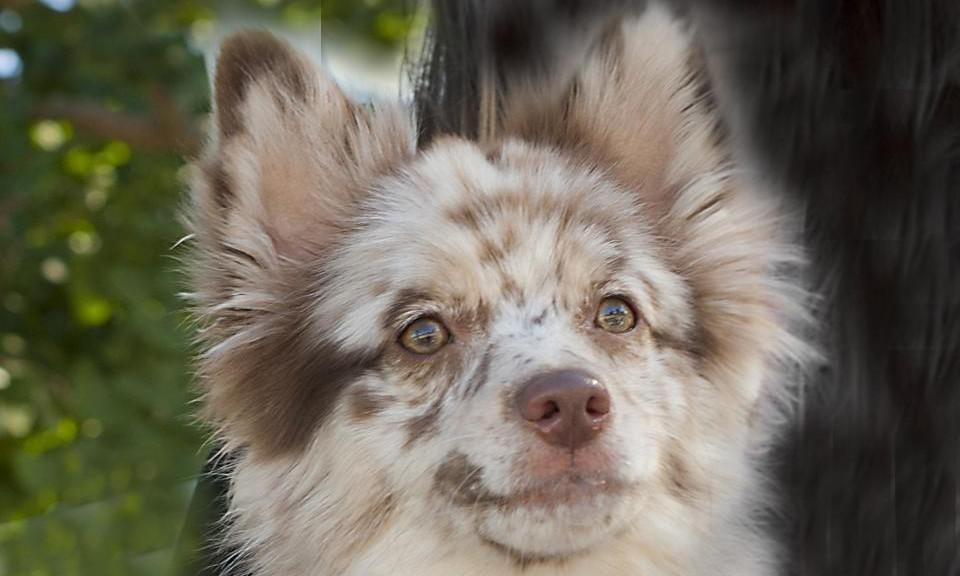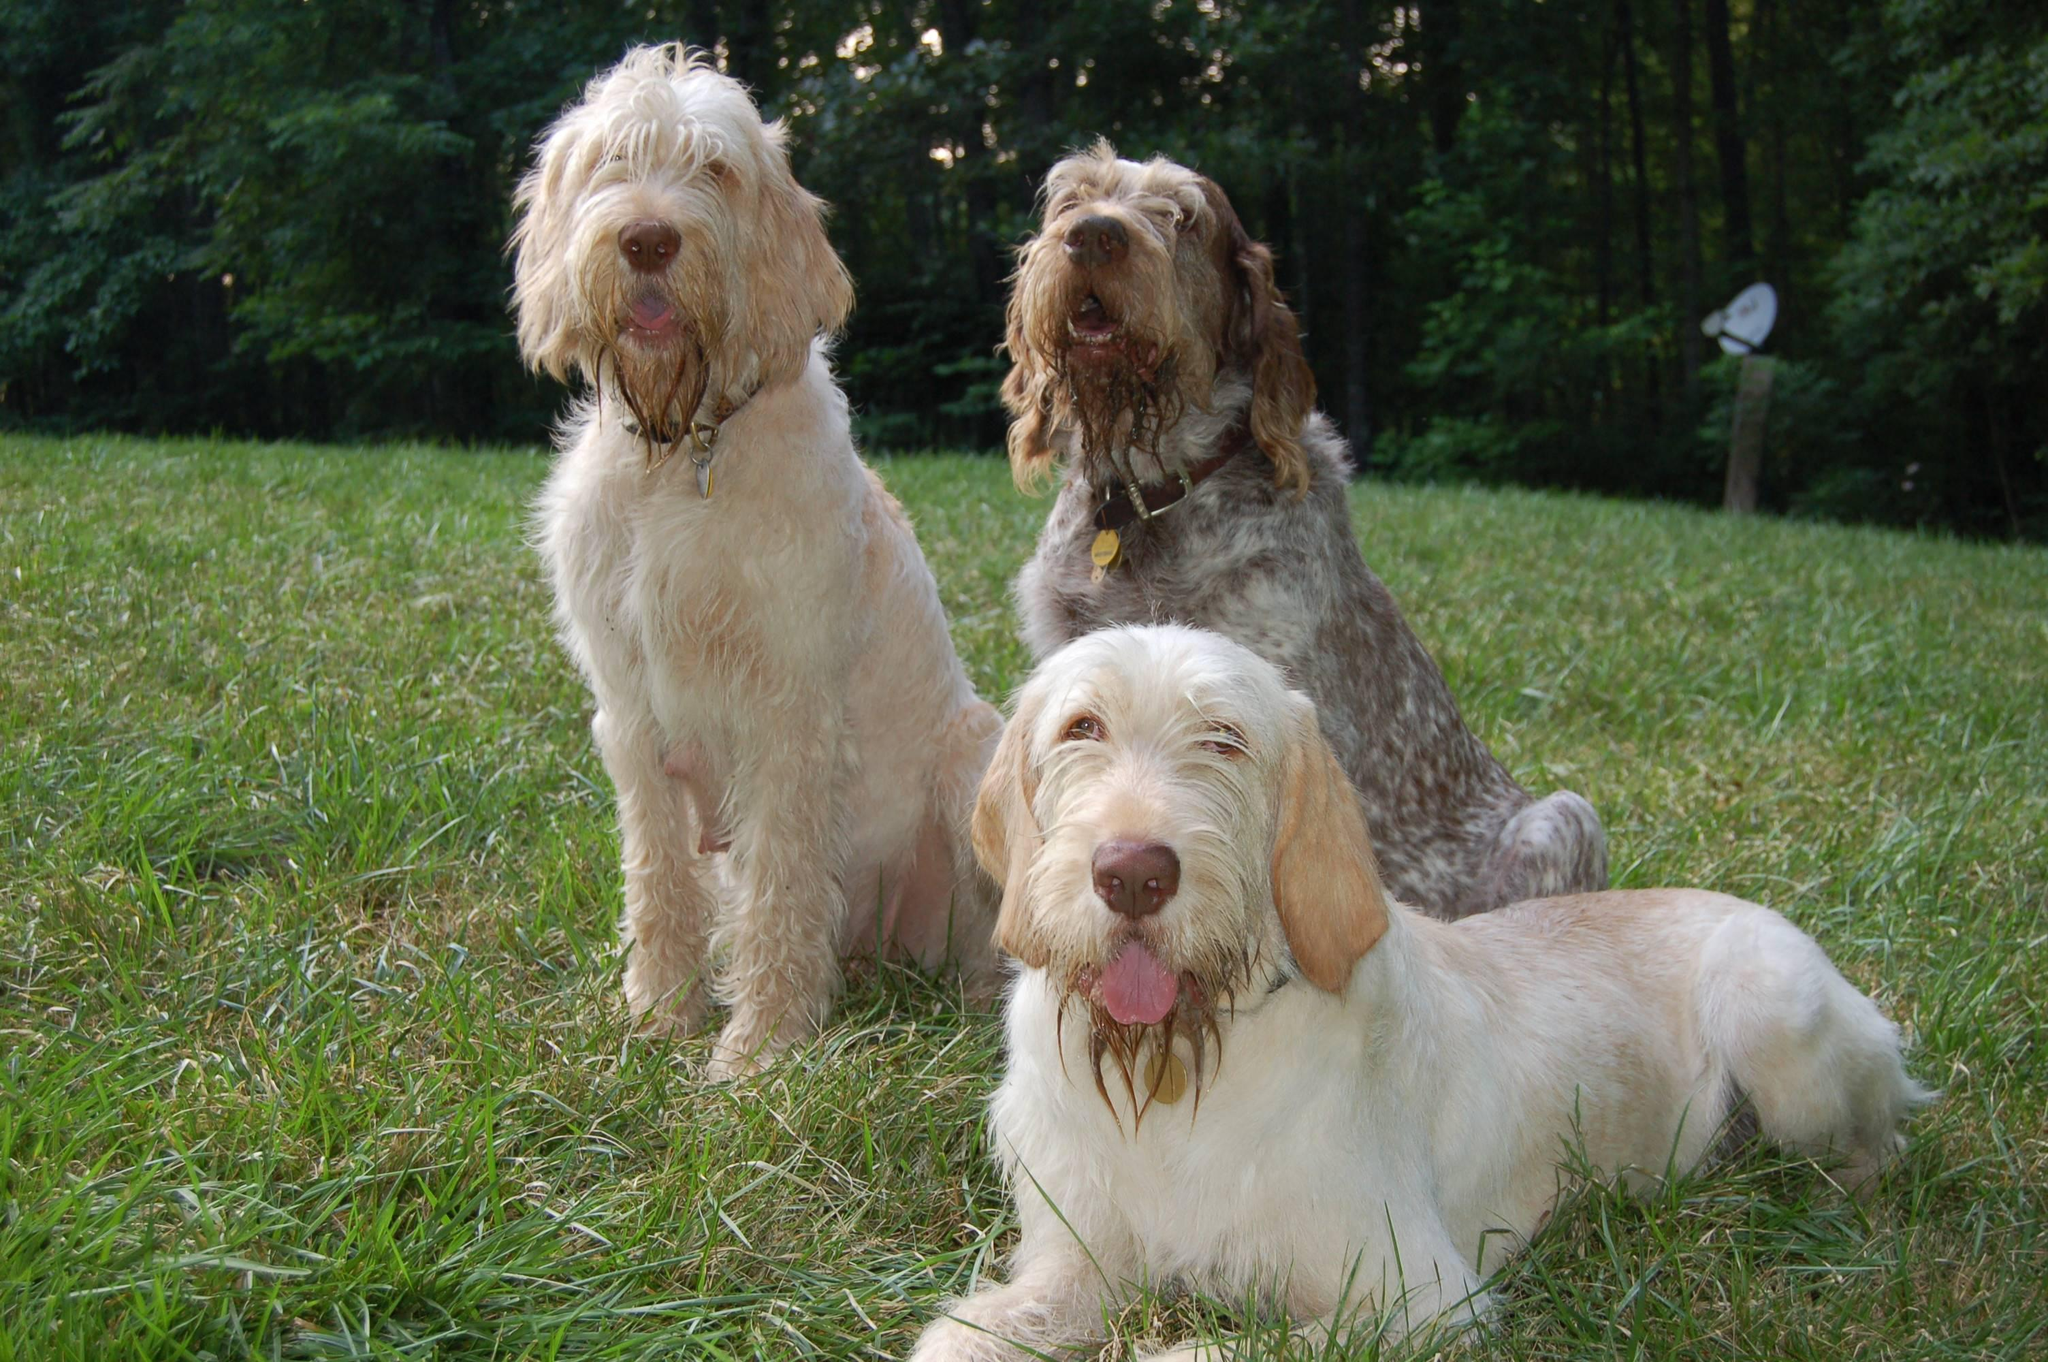The first image is the image on the left, the second image is the image on the right. Given the left and right images, does the statement "At least one image has dogs sitting on grass." hold true? Answer yes or no. Yes. 